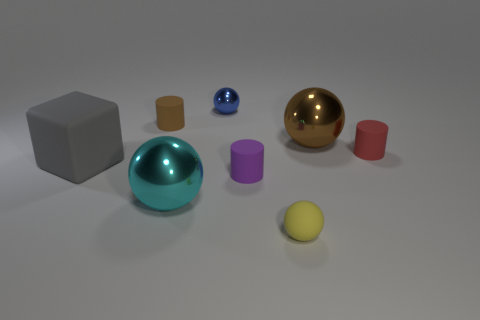What is the color of the tiny sphere that is the same material as the small brown cylinder?
Make the answer very short. Yellow. Is the number of large blue rubber things less than the number of small metal things?
Provide a succinct answer. Yes. How many yellow things are matte spheres or large rubber cubes?
Your response must be concise. 1. How many large shiny objects are to the left of the tiny metallic object and behind the small red cylinder?
Keep it short and to the point. 0. Is the gray thing made of the same material as the big cyan sphere?
Your response must be concise. No. The cyan object that is the same size as the gray rubber block is what shape?
Your answer should be very brief. Sphere. Is the number of purple things greater than the number of small green matte objects?
Offer a terse response. Yes. The object that is both on the left side of the cyan metal object and behind the big brown object is made of what material?
Your answer should be very brief. Rubber. What number of other objects are there of the same material as the purple cylinder?
Ensure brevity in your answer.  4. There is a matte cylinder in front of the red matte cylinder that is on the right side of the big metallic object that is to the right of the cyan thing; what size is it?
Give a very brief answer. Small. 